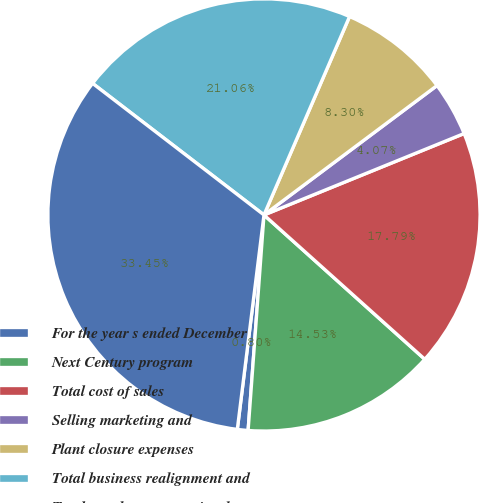<chart> <loc_0><loc_0><loc_500><loc_500><pie_chart><fcel>For the year s ended December<fcel>Next Century program<fcel>Total cost of sales<fcel>Selling marketing and<fcel>Plant closure expenses<fcel>Total business realignment and<fcel>Total net charges associated<nl><fcel>0.8%<fcel>14.53%<fcel>17.79%<fcel>4.07%<fcel>8.3%<fcel>21.06%<fcel>33.45%<nl></chart> 